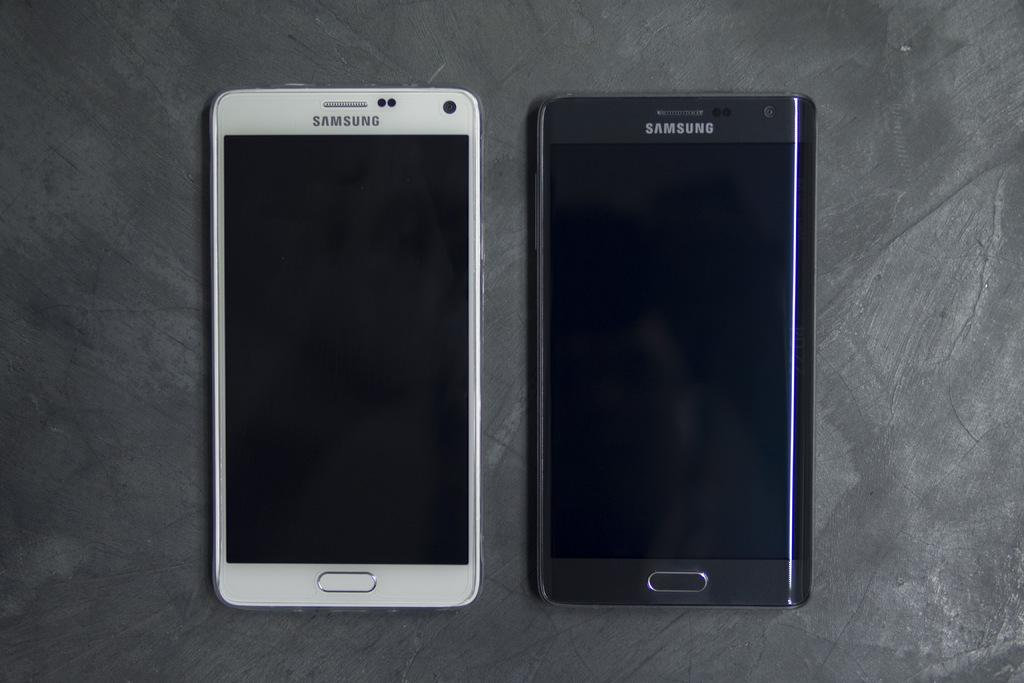<image>
Give a short and clear explanation of the subsequent image. The white and black cell phones lying next to each other both say "SAMSUNG" across the top. 